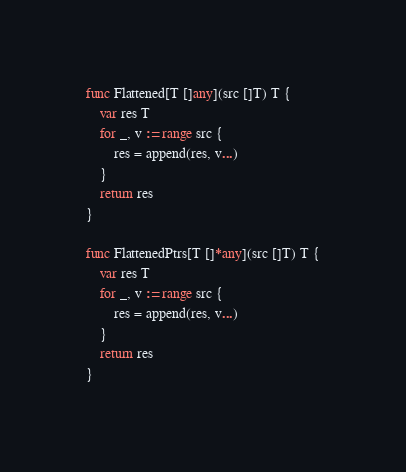Convert code to text. <code><loc_0><loc_0><loc_500><loc_500><_Go_>
func Flattened[T []any](src []T) T {
	var res T
	for _, v := range src {
		res = append(res, v...)
	}
	return res
}

func FlattenedPtrs[T []*any](src []T) T {
	var res T
	for _, v := range src {
		res = append(res, v...)
	}
	return res
}
</code> 